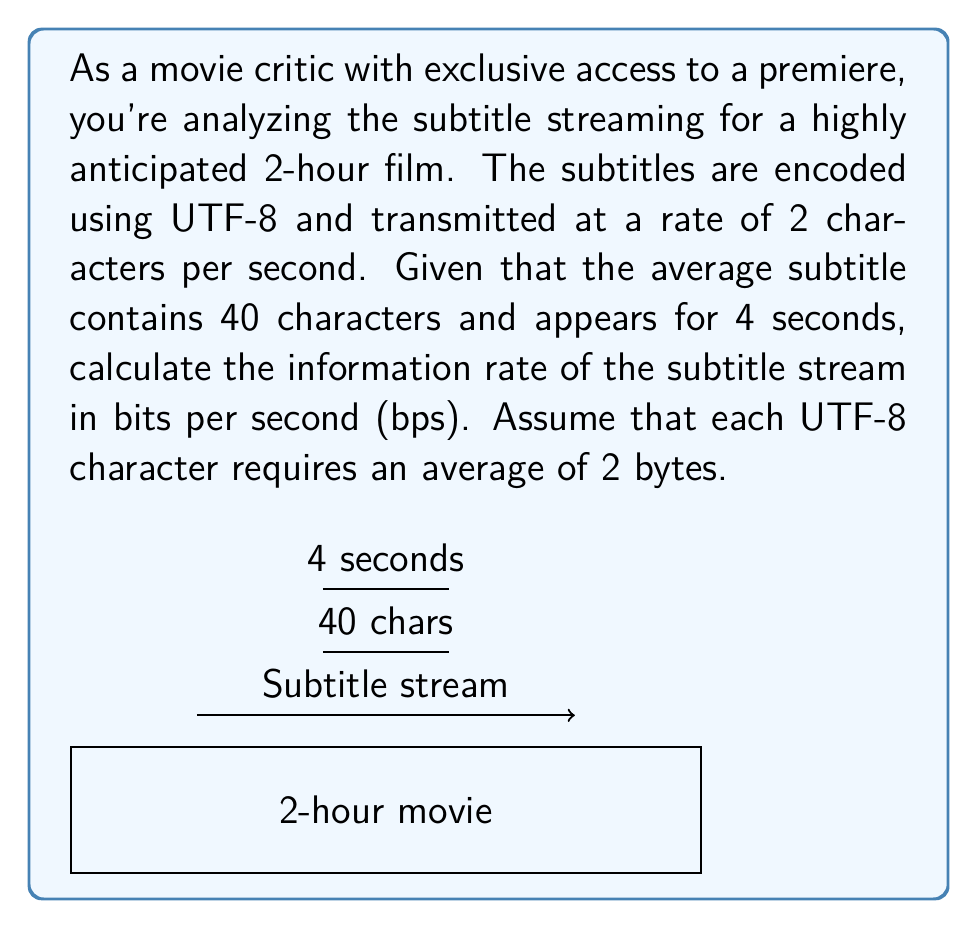What is the answer to this math problem? Let's break this down step-by-step:

1) First, we need to calculate the number of bits per character:
   UTF-8 uses 2 bytes per character on average
   $$ 2 \text{ bytes} \times 8 \text{ bits/byte} = 16 \text{ bits/character} $$

2) Now, let's calculate the number of characters transmitted per second:
   $$ 2 \text{ characters/second} $$

3) The information rate in bits per second is:
   $$ 2 \text{ characters/second} \times 16 \text{ bits/character} = 32 \text{ bps} $$

4) However, this is the raw transmission rate. We need to consider the actual information content of the subtitles.

5) Each subtitle contains 40 characters and appears for 4 seconds. So the actual information rate is:
   $$ \frac{40 \text{ characters}}{4 \text{ seconds}} = 10 \text{ characters/second} $$

6) Converting this to bits per second:
   $$ 10 \text{ characters/second} \times 16 \text{ bits/character} = 160 \text{ bps} $$

Therefore, the information rate of the subtitle stream is 160 bps.
Answer: 160 bps 